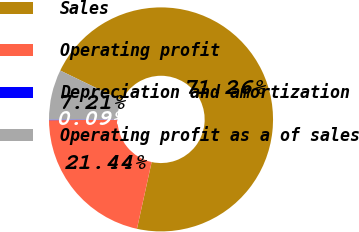Convert chart to OTSL. <chart><loc_0><loc_0><loc_500><loc_500><pie_chart><fcel>Sales<fcel>Operating profit<fcel>Depreciation and amortization<fcel>Operating profit as a of sales<nl><fcel>71.26%<fcel>21.44%<fcel>0.09%<fcel>7.21%<nl></chart> 